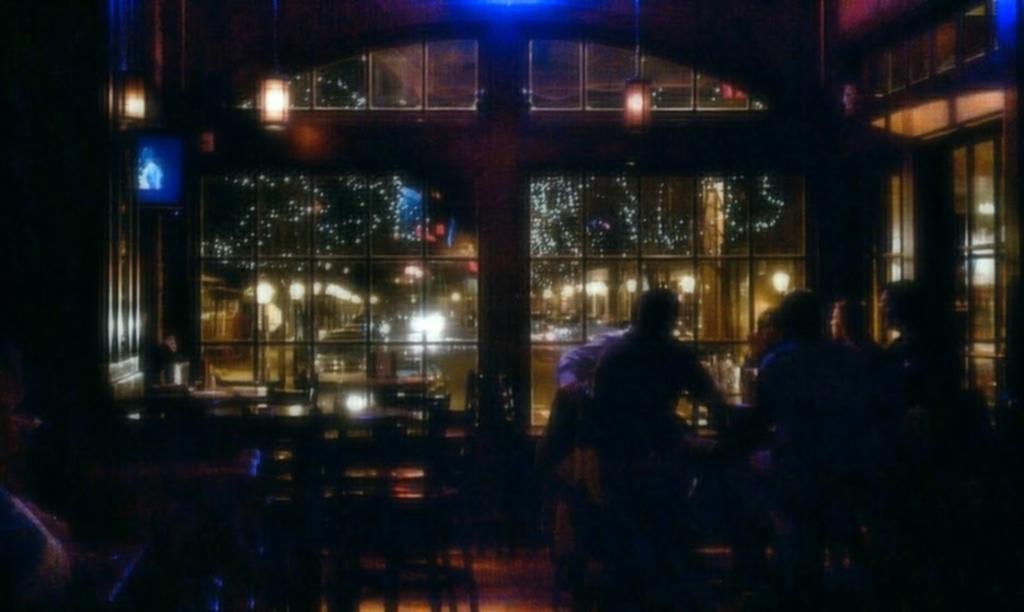In one or two sentences, can you explain what this image depicts? In the picture I can see few persons sitting in chairs in the right corner and there is a table in between them and there are few chairs and a table behind them and there is a glass window and some other objects in the background. 